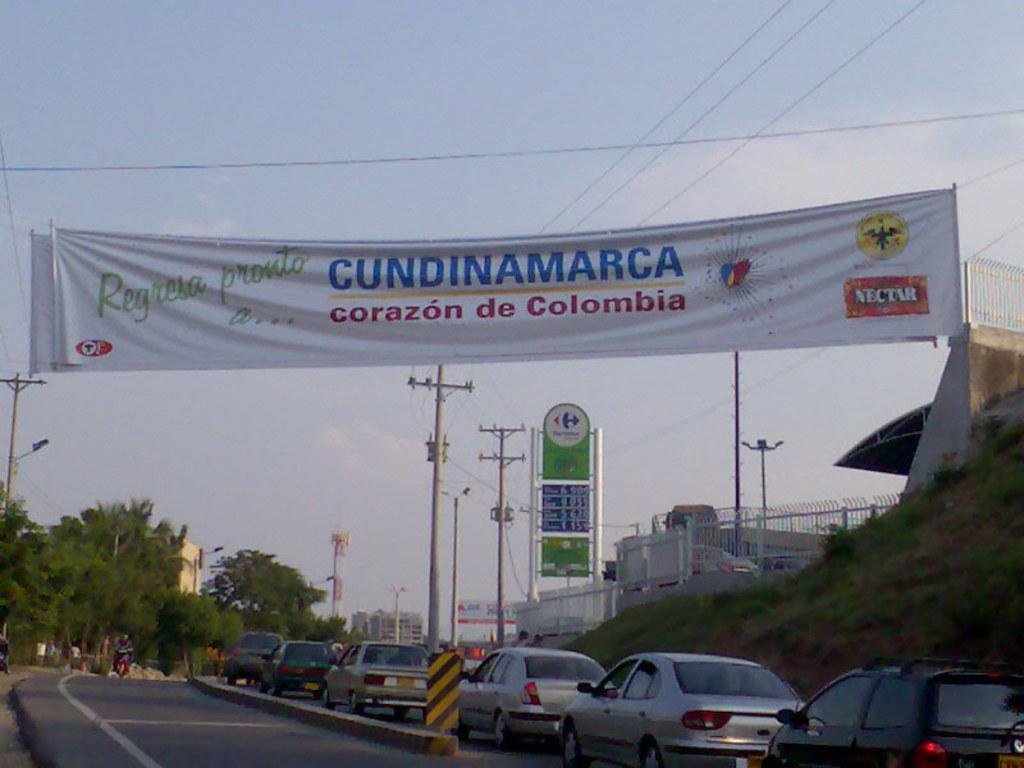What can be seen at the bottom of the image? At the bottom of the image, there are cars, current polls, cables, buildings, trees, a street light, and grass. What is present in the center of the image? There are banners in the center of the image. How would you describe the weather in the image? The sky is sunny in the image. What type of achievement is the person in the image celebrating with their stomach? There is no person or stomach present in the image, so it is not possible to answer that question. 